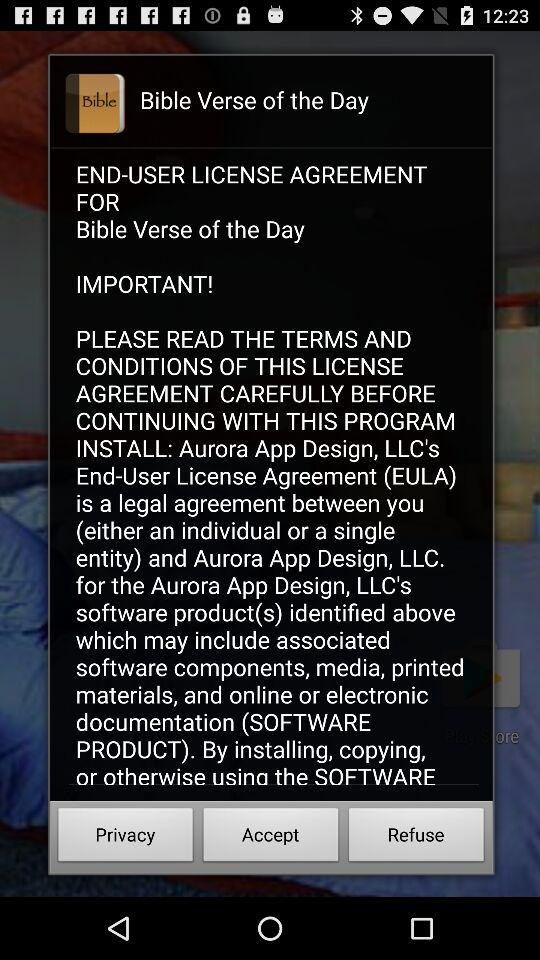What is the name of the application? The name of the application is "Bible Verse of the Day". 